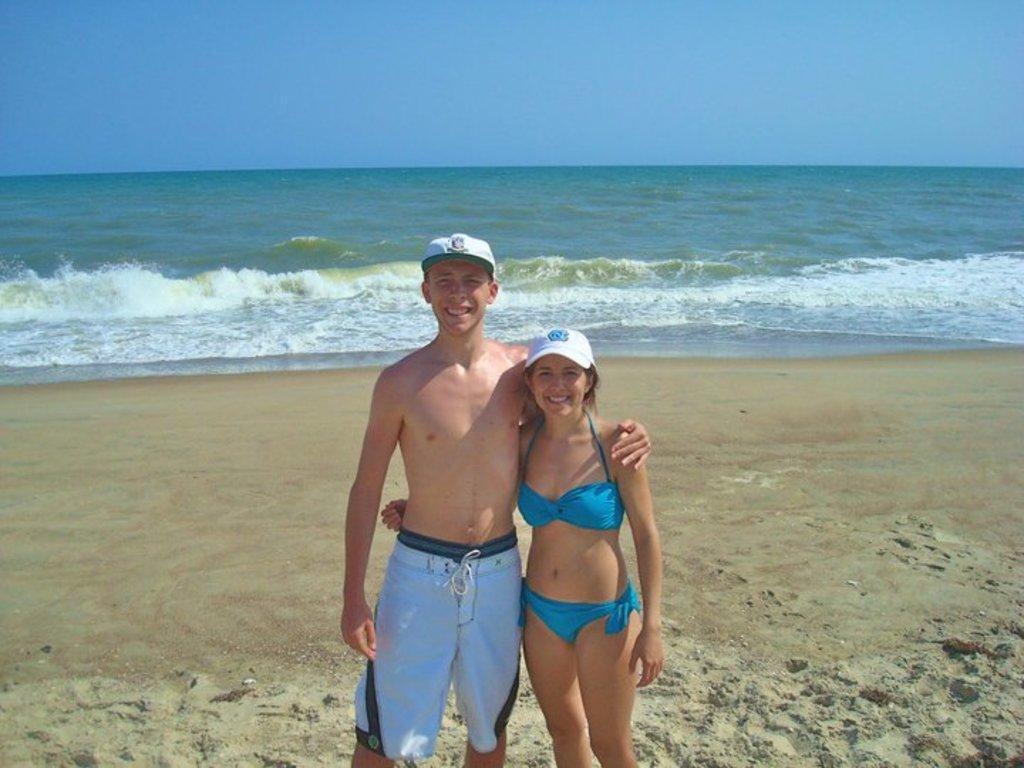How would you summarize this image in a sentence or two? In the picture two people are posing for the photo, they are standing on the sand in front of a sea. 